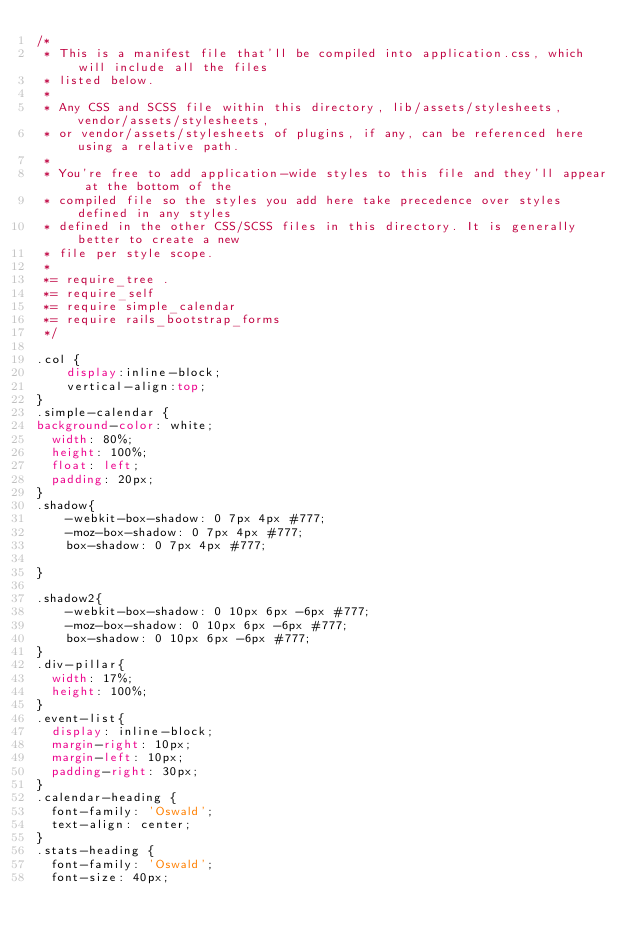Convert code to text. <code><loc_0><loc_0><loc_500><loc_500><_CSS_>/*
 * This is a manifest file that'll be compiled into application.css, which will include all the files
 * listed below.
 *
 * Any CSS and SCSS file within this directory, lib/assets/stylesheets, vendor/assets/stylesheets,
 * or vendor/assets/stylesheets of plugins, if any, can be referenced here using a relative path.
 *
 * You're free to add application-wide styles to this file and they'll appear at the bottom of the
 * compiled file so the styles you add here take precedence over styles defined in any styles
 * defined in the other CSS/SCSS files in this directory. It is generally better to create a new
 * file per style scope.
 *
 *= require_tree .
 *= require_self
 *= require simple_calendar
 *= require rails_bootstrap_forms
 */

.col {
    display:inline-block;
    vertical-align:top;
}
.simple-calendar {
background-color: white;
  width: 80%;
  height: 100%;
  float: left;
  padding: 20px;
}
.shadow{
    -webkit-box-shadow: 0 7px 4px #777;
    -moz-box-shadow: 0 7px 4px #777;
    box-shadow: 0 7px 4px #777;

}

.shadow2{
    -webkit-box-shadow: 0 10px 6px -6px #777;
    -moz-box-shadow: 0 10px 6px -6px #777;
    box-shadow: 0 10px 6px -6px #777;
}
.div-pillar{
  width: 17%;
  height: 100%;
}
.event-list{
  display: inline-block;
  margin-right: 10px;
  margin-left: 10px;
  padding-right: 30px;
}
.calendar-heading {
  font-family: 'Oswald';
  text-align: center;
}
.stats-heading {
  font-family: 'Oswald';
  font-size: 40px;</code> 